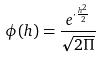<formula> <loc_0><loc_0><loc_500><loc_500>\phi ( h ) = \frac { e ^ { \cdot \frac { h ^ { 2 } } { 2 } } } { \sqrt { 2 \Pi } }</formula> 